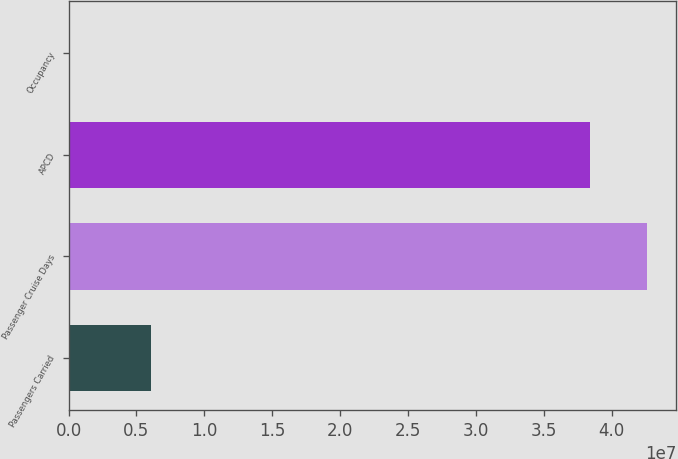Convert chart to OTSL. <chart><loc_0><loc_0><loc_500><loc_500><bar_chart><fcel>Passengers Carried<fcel>Passenger Cruise Days<fcel>APCD<fcel>Occupancy<nl><fcel>6.0842e+06<fcel>4.26106e+07<fcel>3.84253e+07<fcel>108.9<nl></chart> 